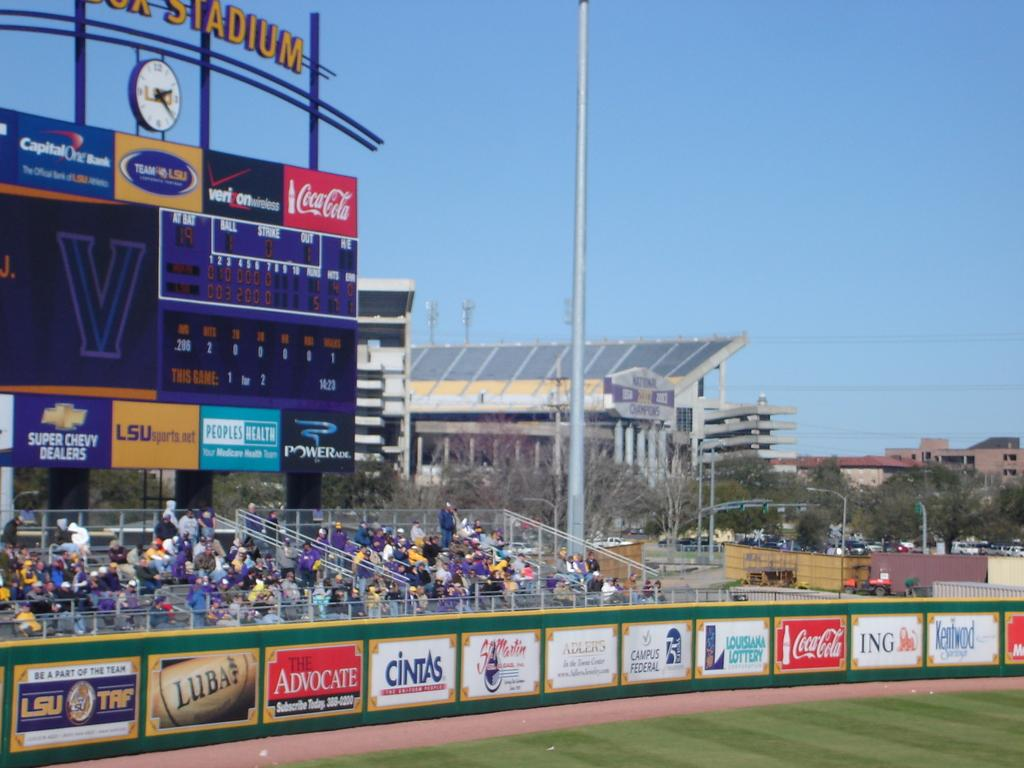<image>
Give a short and clear explanation of the subsequent image. The outfield wall of a baseball stadium from LSU TRF. 